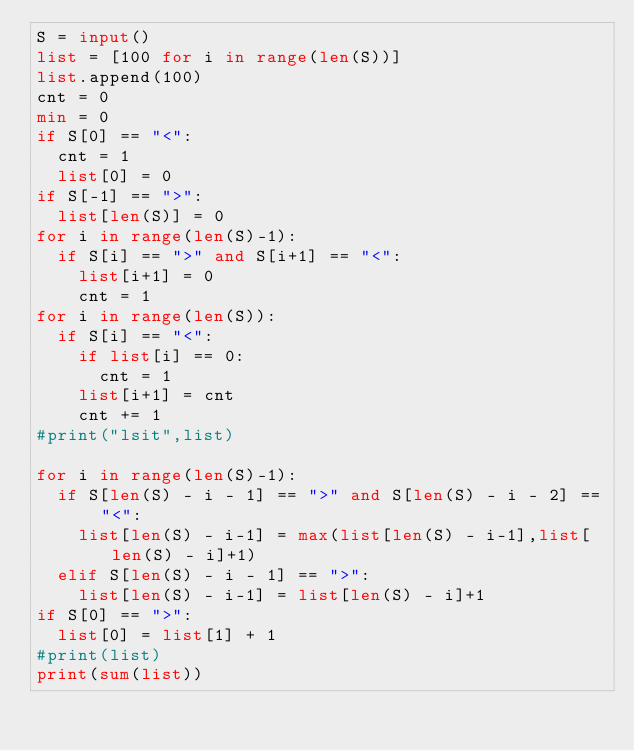<code> <loc_0><loc_0><loc_500><loc_500><_Python_>S = input()
list = [100 for i in range(len(S))]
list.append(100)
cnt = 0
min = 0
if S[0] == "<":
	cnt = 1
	list[0] = 0
if S[-1] == ">":
	list[len(S)] = 0
for i in range(len(S)-1):
	if S[i] == ">" and S[i+1] == "<":
		list[i+1] = 0
		cnt = 1
for i in range(len(S)):
	if S[i] == "<":
		if list[i] == 0:
			cnt = 1
		list[i+1] = cnt
		cnt += 1
#print("lsit",list)

for i in range(len(S)-1):
	if S[len(S) - i - 1] == ">" and S[len(S) - i - 2] == "<":
		list[len(S) - i-1] = max(list[len(S) - i-1],list[len(S) - i]+1)
	elif S[len(S) - i - 1] == ">":
		list[len(S) - i-1] = list[len(S) - i]+1		
if S[0] == ">":
	list[0] = list[1] + 1
#print(list)
print(sum(list))</code> 